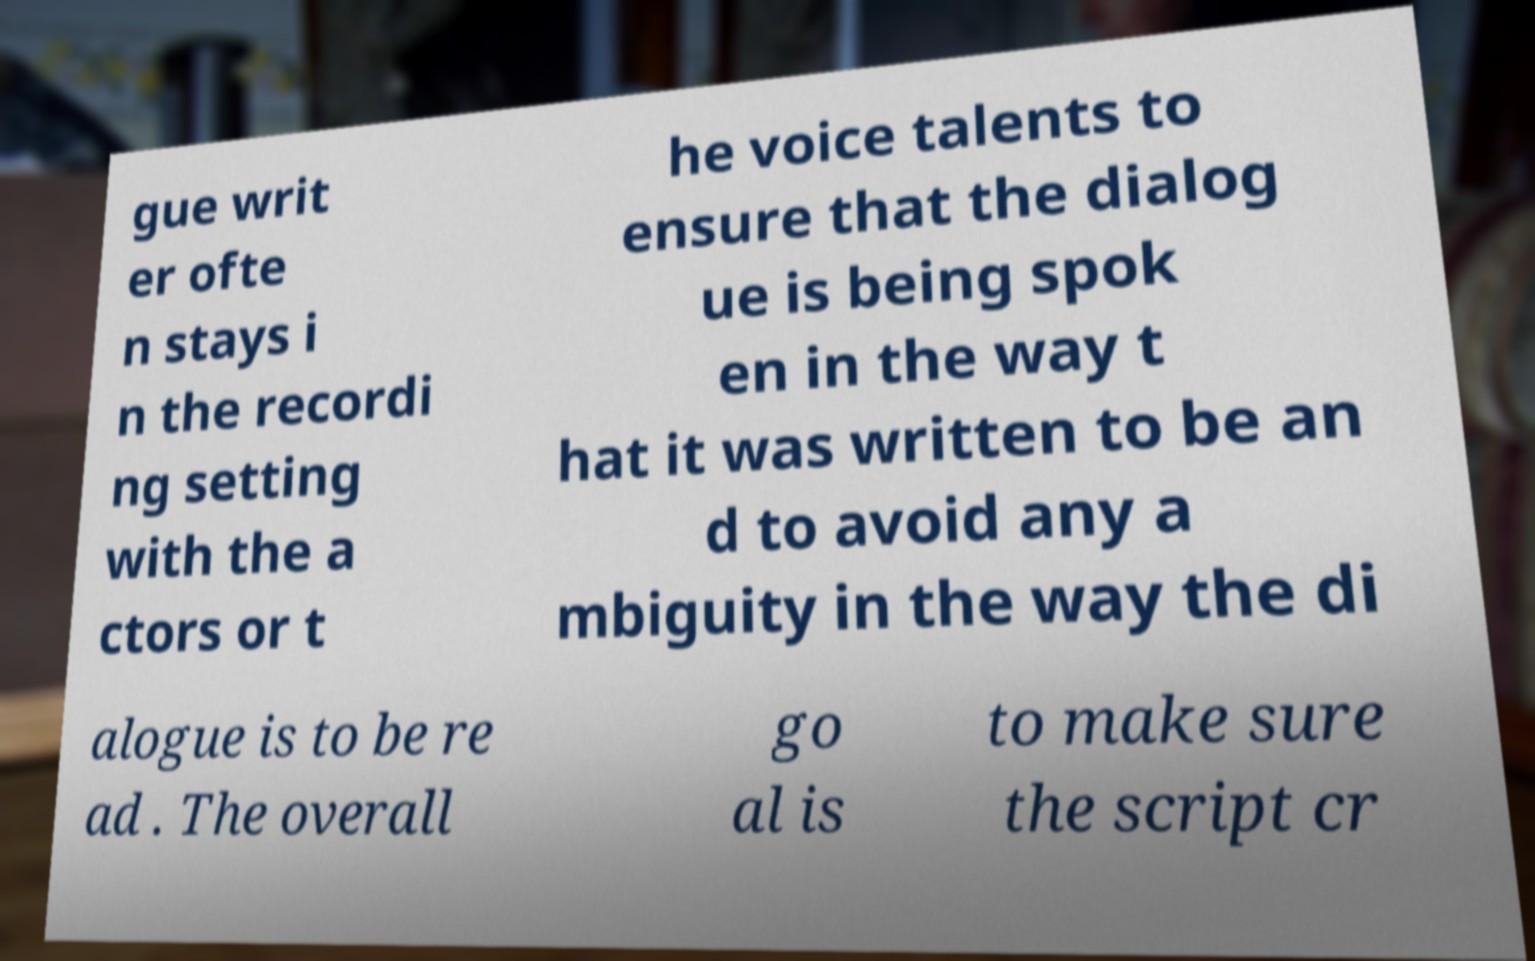Can you accurately transcribe the text from the provided image for me? gue writ er ofte n stays i n the recordi ng setting with the a ctors or t he voice talents to ensure that the dialog ue is being spok en in the way t hat it was written to be an d to avoid any a mbiguity in the way the di alogue is to be re ad . The overall go al is to make sure the script cr 